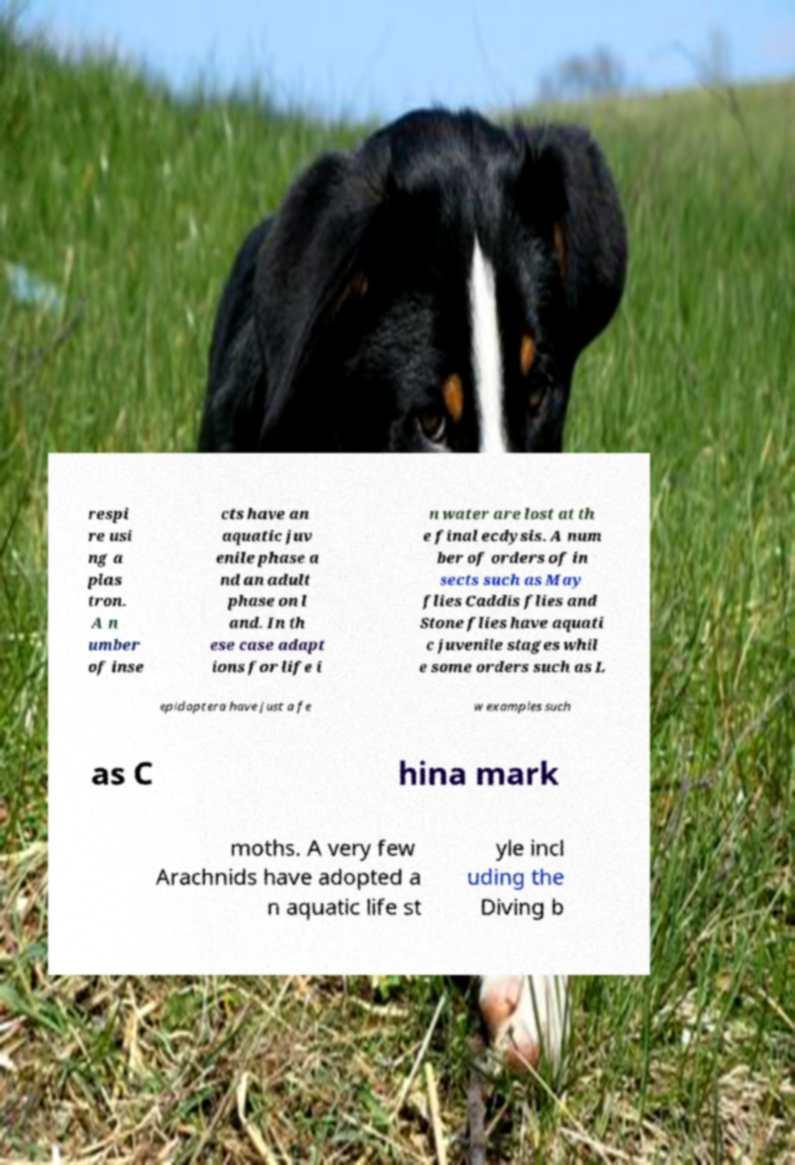There's text embedded in this image that I need extracted. Can you transcribe it verbatim? respi re usi ng a plas tron. A n umber of inse cts have an aquatic juv enile phase a nd an adult phase on l and. In th ese case adapt ions for life i n water are lost at th e final ecdysis. A num ber of orders of in sects such as May flies Caddis flies and Stone flies have aquati c juvenile stages whil e some orders such as L epidoptera have just a fe w examples such as C hina mark moths. A very few Arachnids have adopted a n aquatic life st yle incl uding the Diving b 